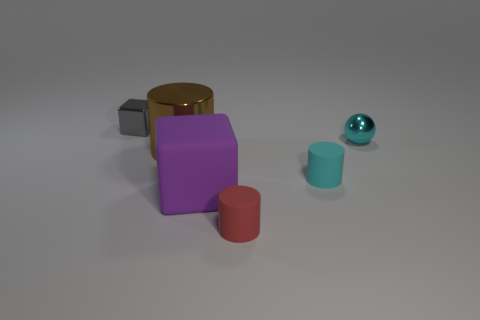Subtract all gray balls. Subtract all gray cylinders. How many balls are left? 1 Add 3 red cylinders. How many objects exist? 9 Subtract all blocks. How many objects are left? 4 Add 5 large metallic objects. How many large metallic objects are left? 6 Add 1 yellow metal cylinders. How many yellow metal cylinders exist? 1 Subtract 0 brown balls. How many objects are left? 6 Subtract all large matte blocks. Subtract all small red cylinders. How many objects are left? 4 